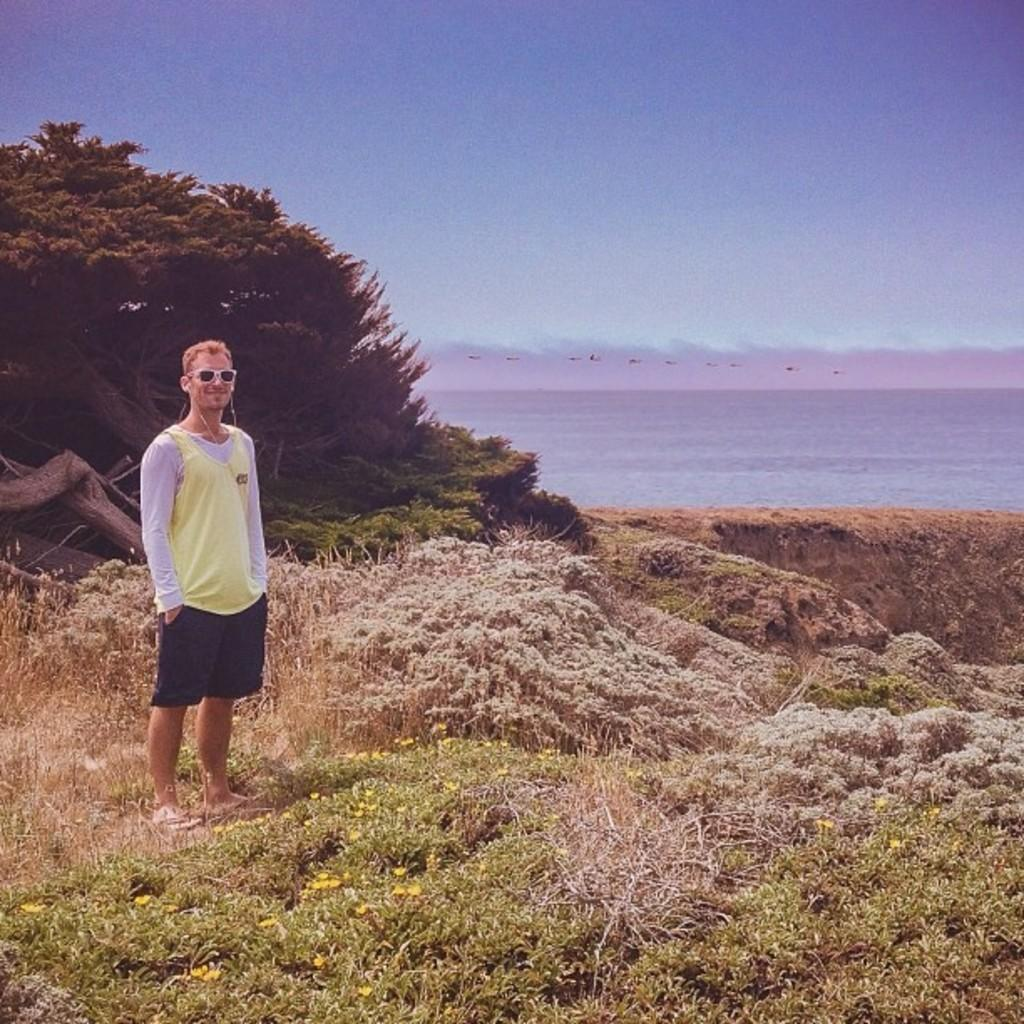What is the person in the image wearing on their face? The person is wearing goggles. What is the person in the image wearing on their ears? The person is wearing earphones. What type of flora can be seen in the image? There are flowers, plants, and trees in the image. What type of fauna can be seen in the image? There are birds flying in the image. Where are the birds flying in the image? The birds are flying over water in the image. What part of the natural environment is visible in the image? The sky is visible in the image. How many fingers does the person have on their left hand in the image? There is no information provided about the person's fingers in the image, so we cannot determine the number of fingers on their left hand. 